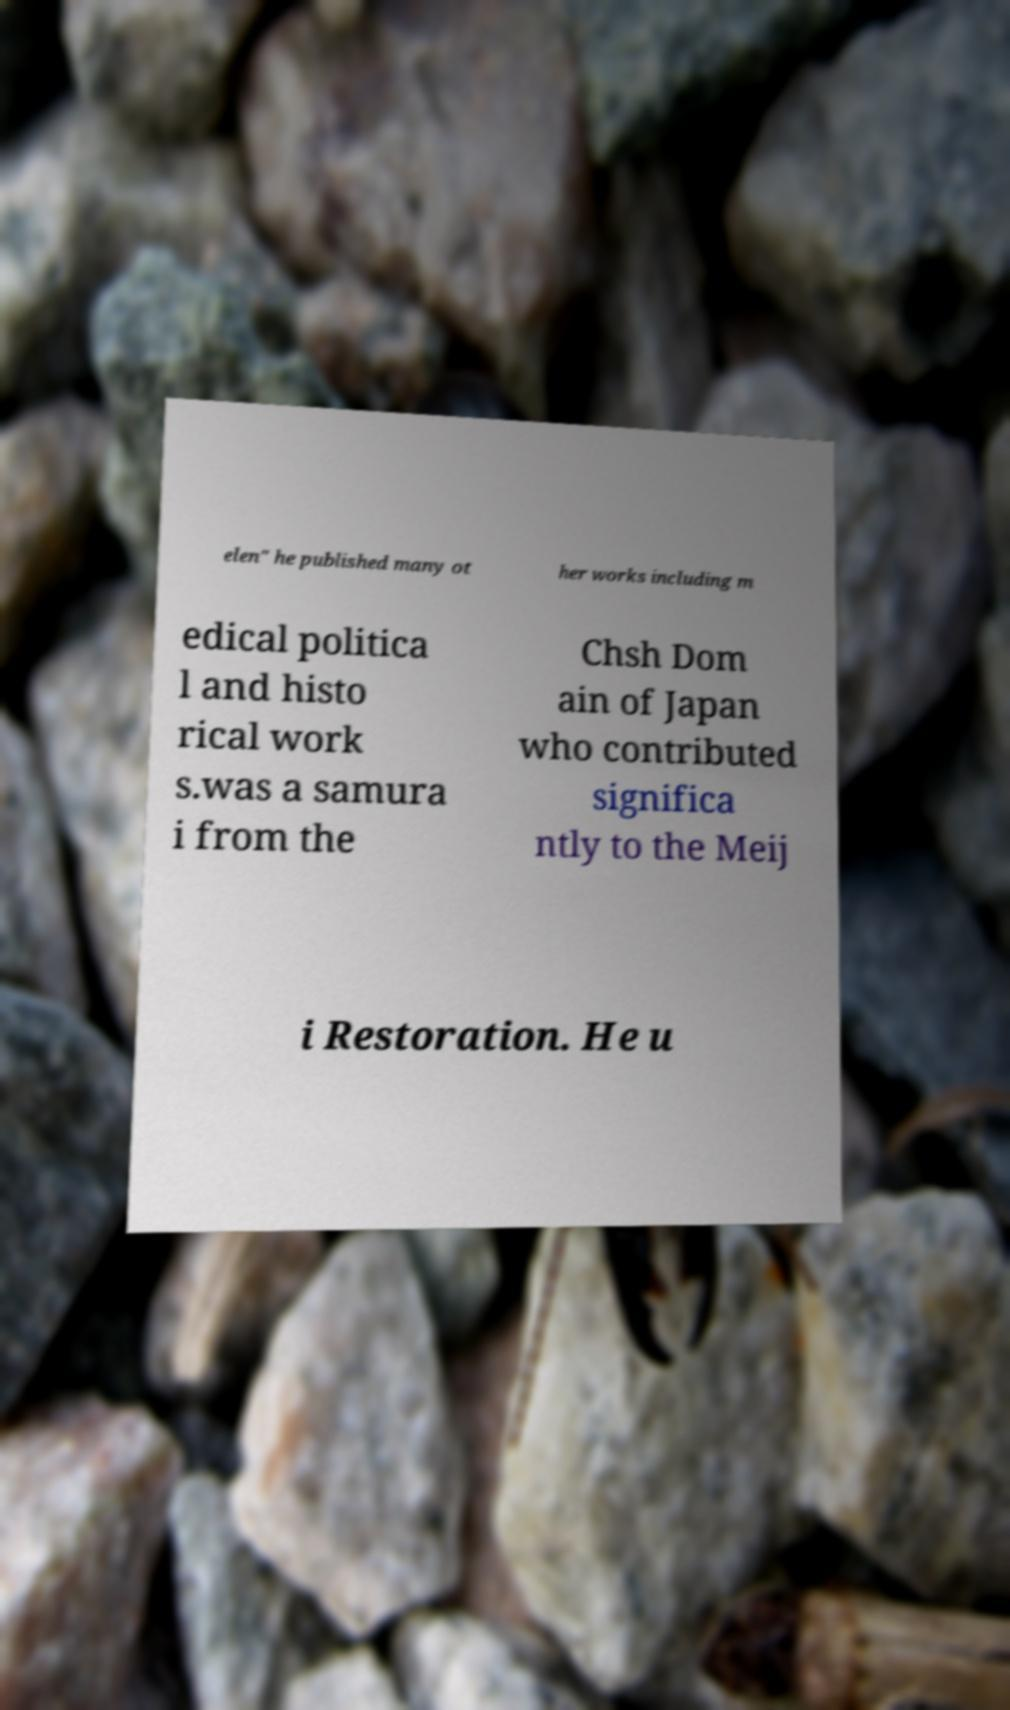Please read and relay the text visible in this image. What does it say? elen" he published many ot her works including m edical politica l and histo rical work s.was a samura i from the Chsh Dom ain of Japan who contributed significa ntly to the Meij i Restoration. He u 